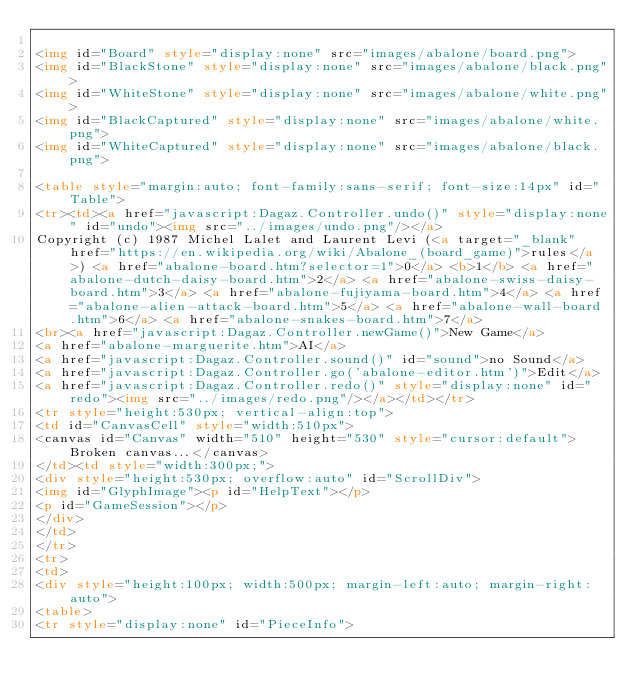Convert code to text. <code><loc_0><loc_0><loc_500><loc_500><_HTML_>
<img id="Board" style="display:none" src="images/abalone/board.png">
<img id="BlackStone" style="display:none" src="images/abalone/black.png">
<img id="WhiteStone" style="display:none" src="images/abalone/white.png">
<img id="BlackCaptured" style="display:none" src="images/abalone/white.png">
<img id="WhiteCaptured" style="display:none" src="images/abalone/black.png">

<table style="margin:auto; font-family:sans-serif; font-size:14px" id="Table">
<tr><td><a href="javascript:Dagaz.Controller.undo()" style="display:none" id="undo"><img src="../images/undo.png"/></a>
Copyright (c) 1987 Michel Lalet and Laurent Levi (<a target="_blank" href="https://en.wikipedia.org/wiki/Abalone_(board_game)">rules</a>) <a href="abalone-board.htm?selector=1">0</a> <b>1</b> <a href="abalone-dutch-daisy-board.htm">2</a> <a href="abalone-swiss-daisy-board.htm">3</a> <a href="abalone-fujiyama-board.htm">4</a> <a href="abalone-alien-attack-board.htm">5</a> <a href="abalone-wall-board.htm">6</a> <a href="abalone-snakes-board.htm">7</a>
<br><a href="javascript:Dagaz.Controller.newGame()">New Game</a>
<a href="abalone-marguerite.htm">AI</a>
<a href="javascript:Dagaz.Controller.sound()" id="sound">no Sound</a>
<a href="javascript:Dagaz.Controller.go('abalone-editor.htm')">Edit</a>
<a href="javascript:Dagaz.Controller.redo()" style="display:none" id="redo"><img src="../images/redo.png"/></a></td></tr>
<tr style="height:530px; vertical-align:top">
<td id="CanvasCell" style="width:510px">
<canvas id="Canvas" width="510" height="530" style="cursor:default">Broken canvas...</canvas>
</td><td style="width:300px;">
<div style="height:530px; overflow:auto" id="ScrollDiv">
<img id="GlyphImage"><p id="HelpText"></p>
<p id="GameSession"></p>
</div>
</td>
</tr>
<tr>
<td>
<div style="height:100px; width:500px; margin-left:auto; margin-right:auto">
<table>
<tr style="display:none" id="PieceInfo"></code> 